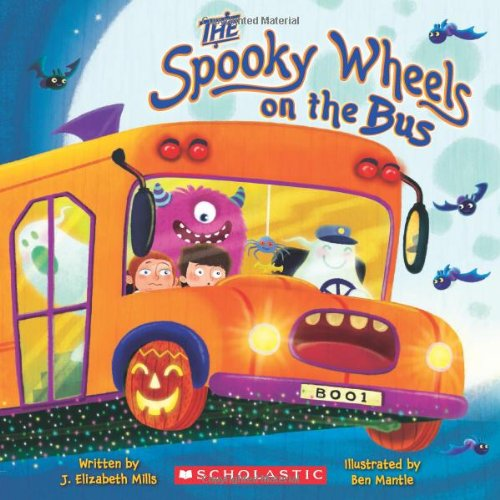How do you think the illustrations contribute to the child's experience of reading this book? The illustrations in 'The Spooky Wheels on the Bus,' created by Ben Mantle, use vibrant colors and engaging characters that are both friendly and amusing. These visual elements play a crucial role in drawing children into the story, making the reading experience more engaging and enjoyable by stimulating their imagination and helping them visualize the scenes. 